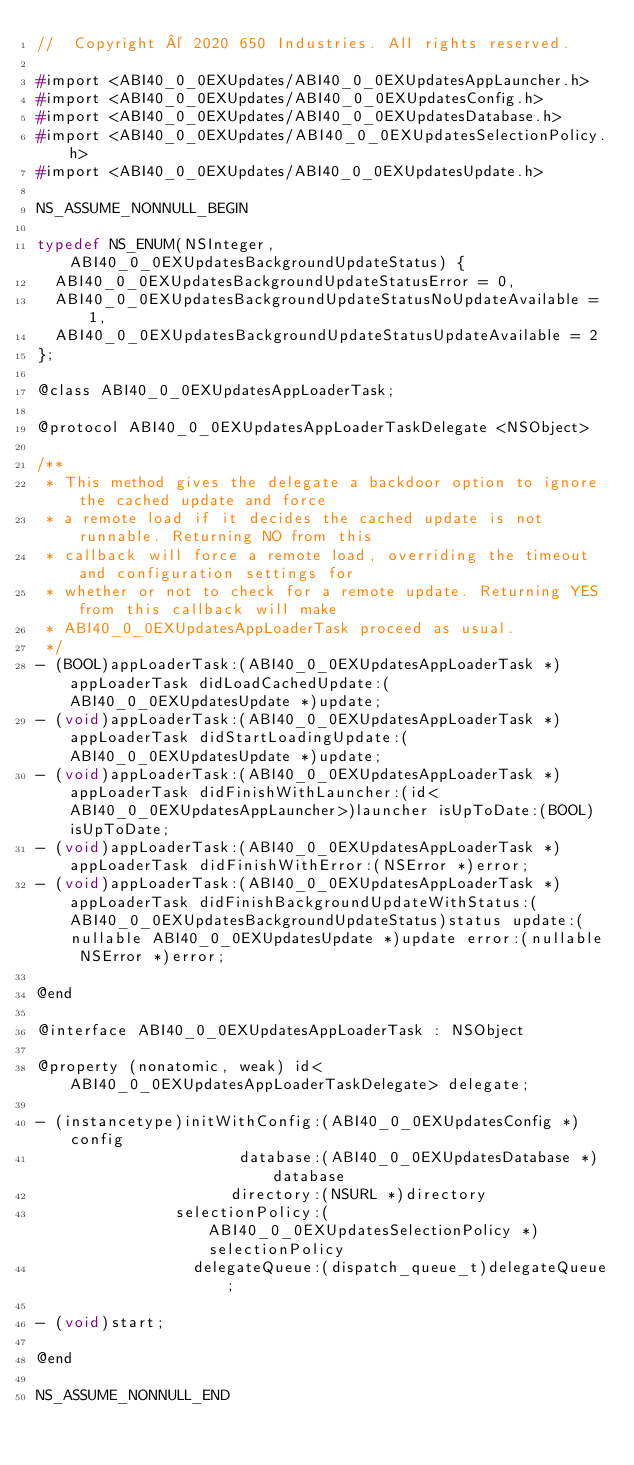Convert code to text. <code><loc_0><loc_0><loc_500><loc_500><_C_>//  Copyright © 2020 650 Industries. All rights reserved.

#import <ABI40_0_0EXUpdates/ABI40_0_0EXUpdatesAppLauncher.h>
#import <ABI40_0_0EXUpdates/ABI40_0_0EXUpdatesConfig.h>
#import <ABI40_0_0EXUpdates/ABI40_0_0EXUpdatesDatabase.h>
#import <ABI40_0_0EXUpdates/ABI40_0_0EXUpdatesSelectionPolicy.h>
#import <ABI40_0_0EXUpdates/ABI40_0_0EXUpdatesUpdate.h>

NS_ASSUME_NONNULL_BEGIN

typedef NS_ENUM(NSInteger, ABI40_0_0EXUpdatesBackgroundUpdateStatus) {
  ABI40_0_0EXUpdatesBackgroundUpdateStatusError = 0,
  ABI40_0_0EXUpdatesBackgroundUpdateStatusNoUpdateAvailable = 1,
  ABI40_0_0EXUpdatesBackgroundUpdateStatusUpdateAvailable = 2
};

@class ABI40_0_0EXUpdatesAppLoaderTask;

@protocol ABI40_0_0EXUpdatesAppLoaderTaskDelegate <NSObject>

/**
 * This method gives the delegate a backdoor option to ignore the cached update and force
 * a remote load if it decides the cached update is not runnable. Returning NO from this
 * callback will force a remote load, overriding the timeout and configuration settings for
 * whether or not to check for a remote update. Returning YES from this callback will make
 * ABI40_0_0EXUpdatesAppLoaderTask proceed as usual.
 */
- (BOOL)appLoaderTask:(ABI40_0_0EXUpdatesAppLoaderTask *)appLoaderTask didLoadCachedUpdate:(ABI40_0_0EXUpdatesUpdate *)update;
- (void)appLoaderTask:(ABI40_0_0EXUpdatesAppLoaderTask *)appLoaderTask didStartLoadingUpdate:(ABI40_0_0EXUpdatesUpdate *)update;
- (void)appLoaderTask:(ABI40_0_0EXUpdatesAppLoaderTask *)appLoaderTask didFinishWithLauncher:(id<ABI40_0_0EXUpdatesAppLauncher>)launcher isUpToDate:(BOOL)isUpToDate;
- (void)appLoaderTask:(ABI40_0_0EXUpdatesAppLoaderTask *)appLoaderTask didFinishWithError:(NSError *)error;
- (void)appLoaderTask:(ABI40_0_0EXUpdatesAppLoaderTask *)appLoaderTask didFinishBackgroundUpdateWithStatus:(ABI40_0_0EXUpdatesBackgroundUpdateStatus)status update:(nullable ABI40_0_0EXUpdatesUpdate *)update error:(nullable NSError *)error;

@end

@interface ABI40_0_0EXUpdatesAppLoaderTask : NSObject

@property (nonatomic, weak) id<ABI40_0_0EXUpdatesAppLoaderTaskDelegate> delegate;

- (instancetype)initWithConfig:(ABI40_0_0EXUpdatesConfig *)config
                      database:(ABI40_0_0EXUpdatesDatabase *)database
                     directory:(NSURL *)directory
               selectionPolicy:(ABI40_0_0EXUpdatesSelectionPolicy *)selectionPolicy
                 delegateQueue:(dispatch_queue_t)delegateQueue;

- (void)start;

@end

NS_ASSUME_NONNULL_END
</code> 